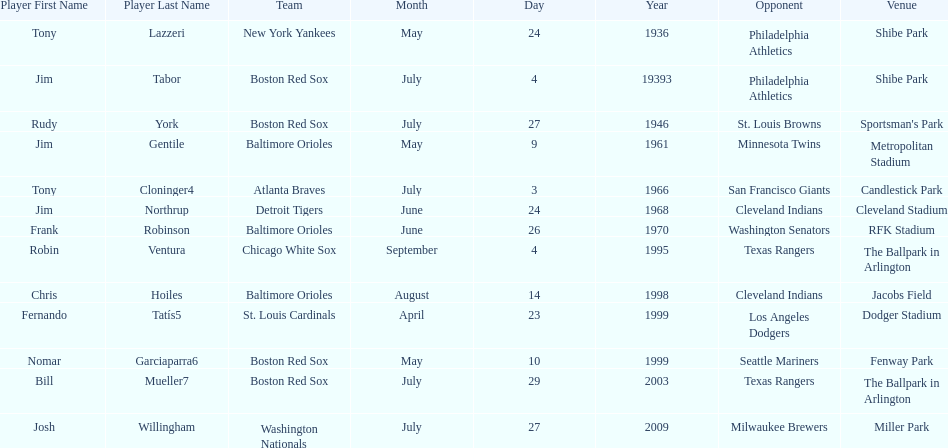Who was the opponent for the boston red sox on july 27, 1946? St. Louis Browns. 